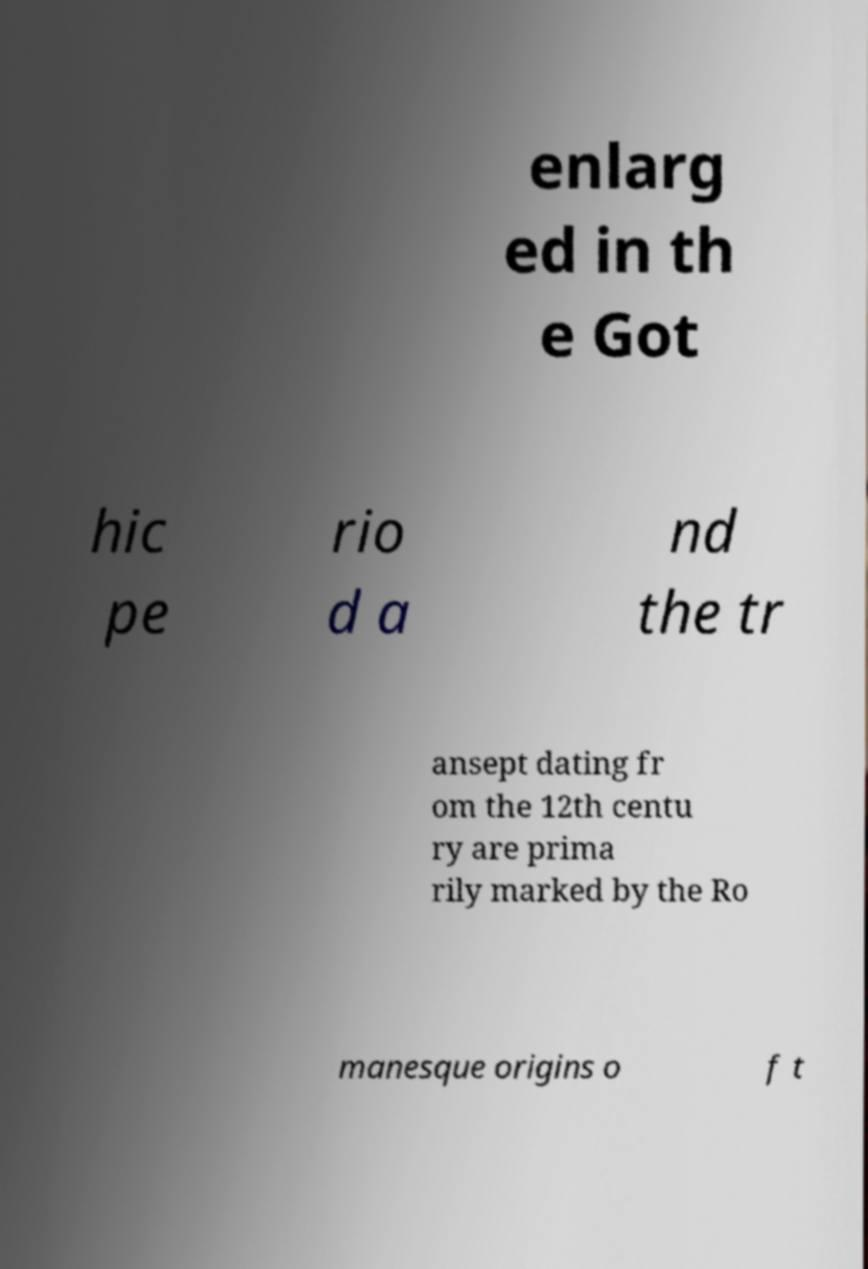Can you read and provide the text displayed in the image?This photo seems to have some interesting text. Can you extract and type it out for me? enlarg ed in th e Got hic pe rio d a nd the tr ansept dating fr om the 12th centu ry are prima rily marked by the Ro manesque origins o f t 